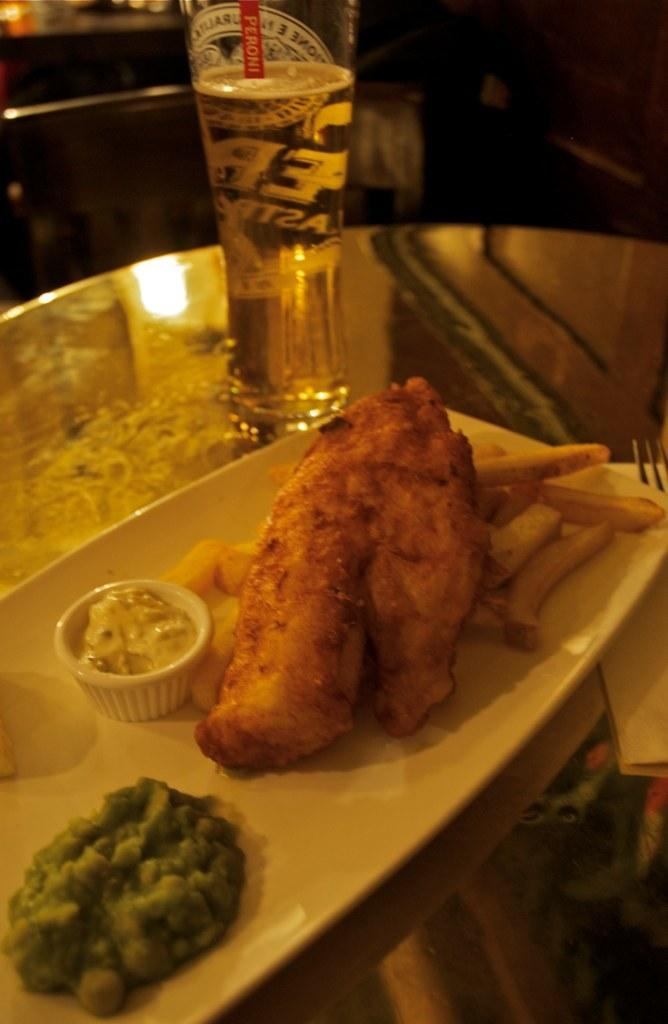<image>
Relay a brief, clear account of the picture shown. A meal of fish, chips and peas with a drink that has the label Peroni. 